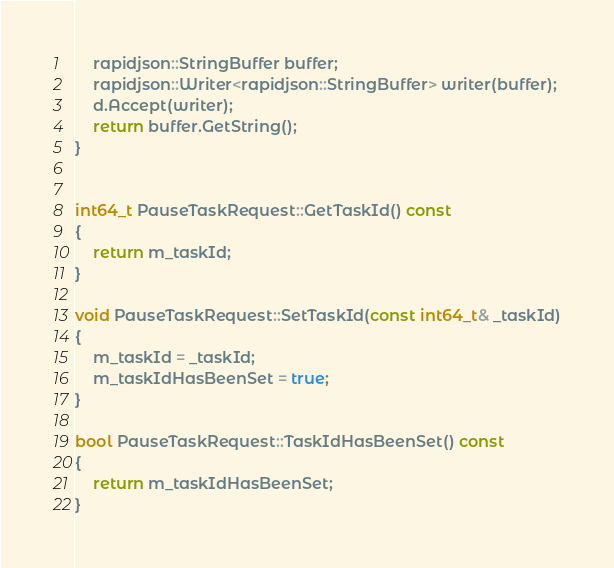<code> <loc_0><loc_0><loc_500><loc_500><_C++_>    rapidjson::StringBuffer buffer;
    rapidjson::Writer<rapidjson::StringBuffer> writer(buffer);
    d.Accept(writer);
    return buffer.GetString();
}


int64_t PauseTaskRequest::GetTaskId() const
{
    return m_taskId;
}

void PauseTaskRequest::SetTaskId(const int64_t& _taskId)
{
    m_taskId = _taskId;
    m_taskIdHasBeenSet = true;
}

bool PauseTaskRequest::TaskIdHasBeenSet() const
{
    return m_taskIdHasBeenSet;
}


</code> 